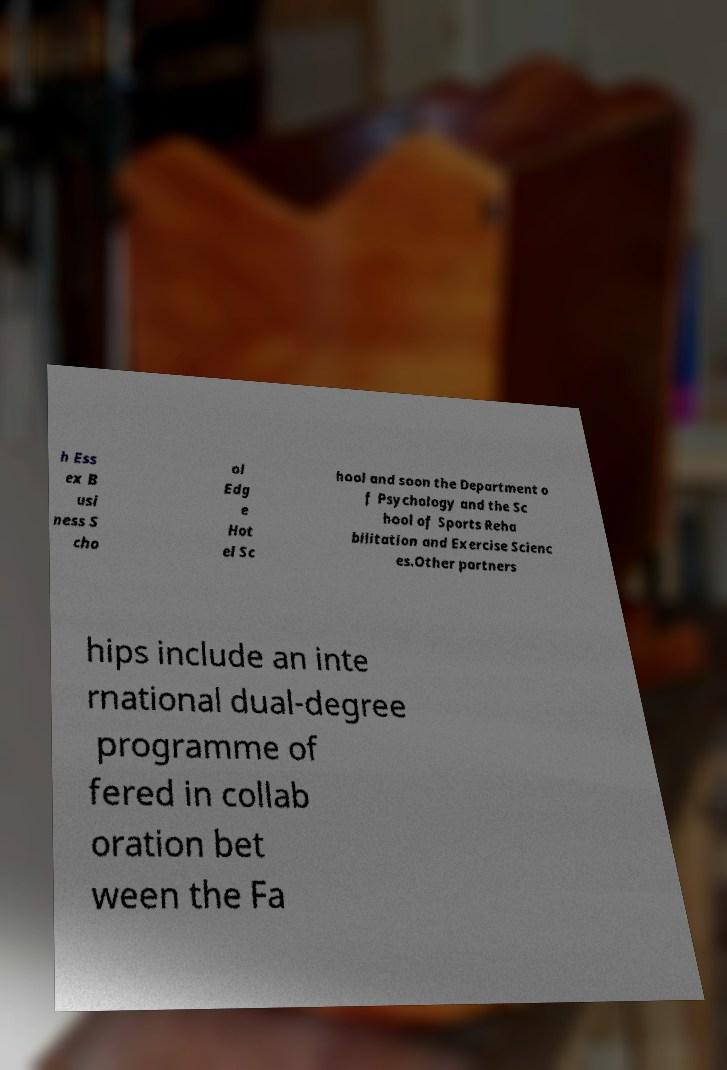Could you extract and type out the text from this image? h Ess ex B usi ness S cho ol Edg e Hot el Sc hool and soon the Department o f Psychology and the Sc hool of Sports Reha bilitation and Exercise Scienc es.Other partners hips include an inte rnational dual-degree programme of fered in collab oration bet ween the Fa 